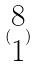Convert formula to latex. <formula><loc_0><loc_0><loc_500><loc_500>( \begin{matrix} 8 \\ 1 \end{matrix} )</formula> 